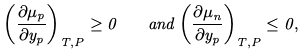Convert formula to latex. <formula><loc_0><loc_0><loc_500><loc_500>\left ( \frac { \partial \mu _ { p } } { \partial y _ { p } } \right ) _ { T , P } \geq 0 \quad a n d \left ( \frac { \partial \mu _ { n } } { \partial y _ { p } } \right ) _ { T , P } \leq 0 ,</formula> 